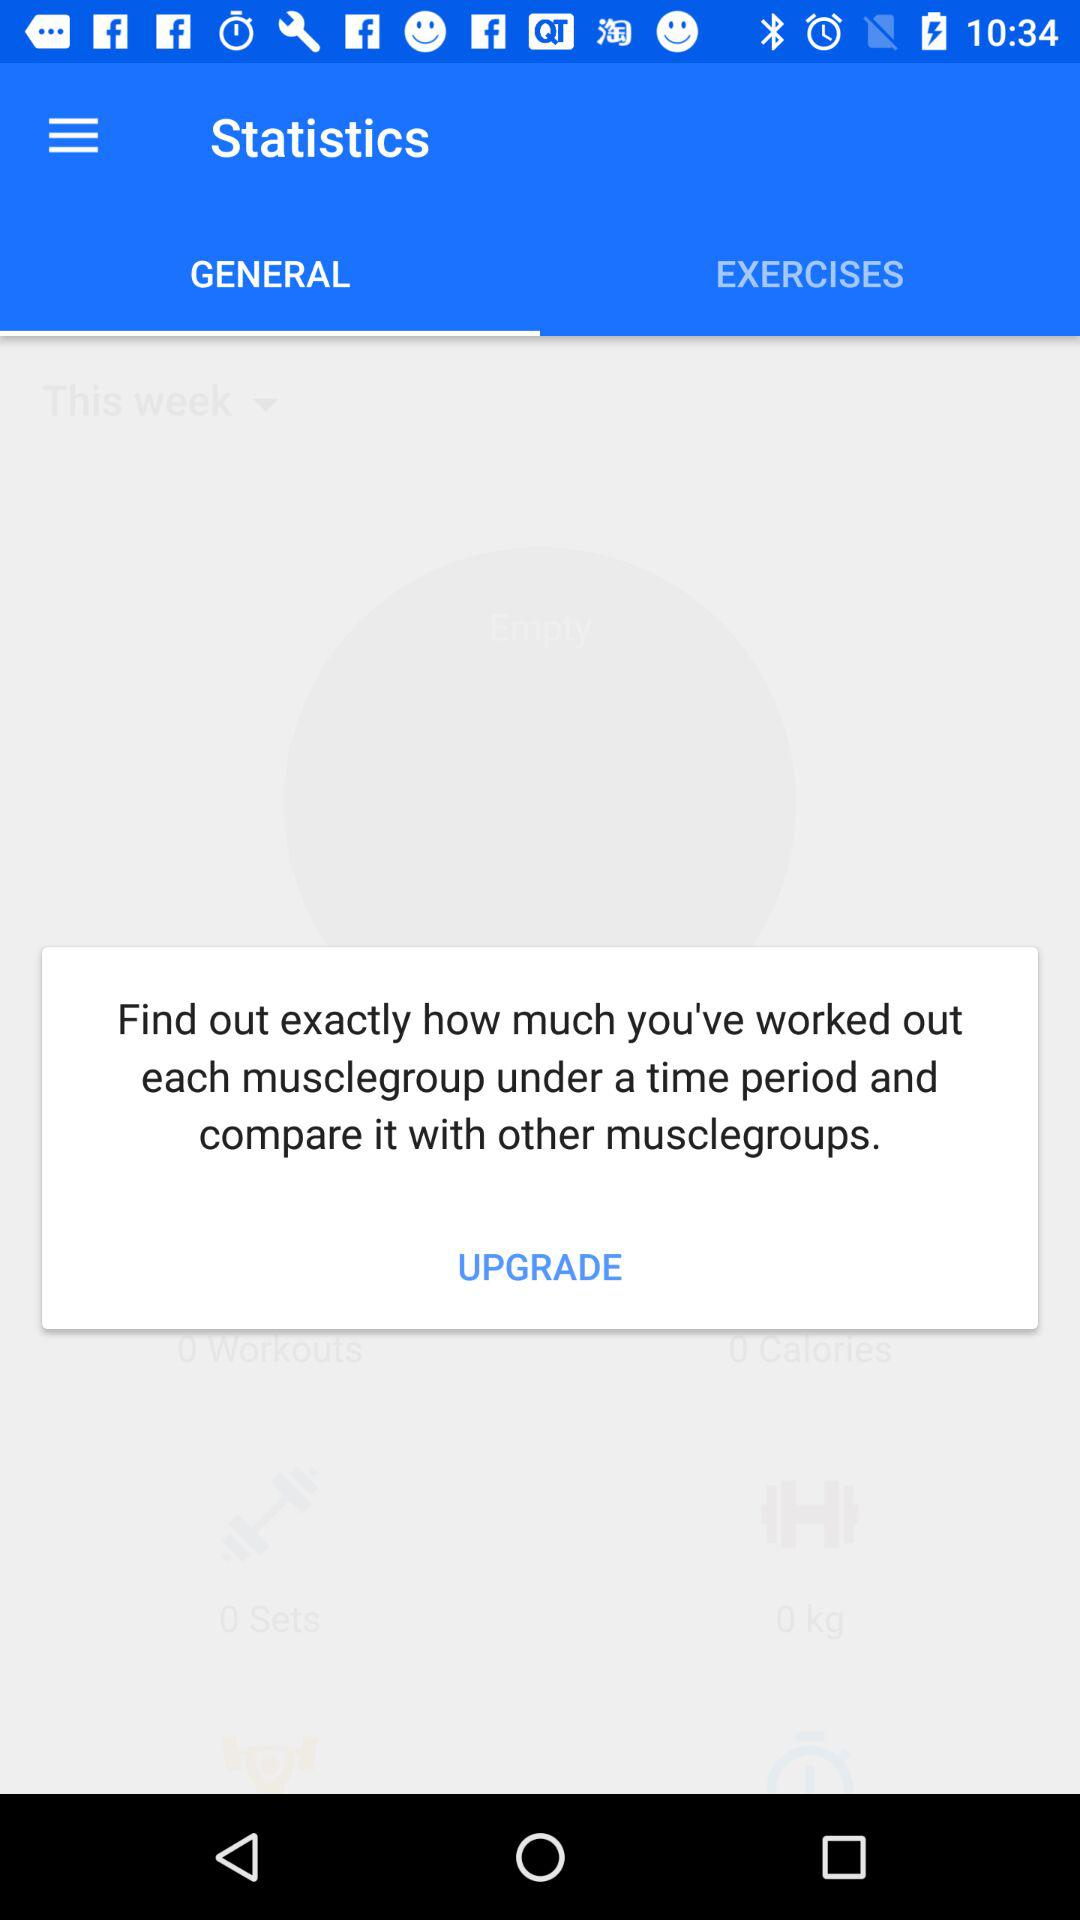Which tab is selected? The selected tab is "GENERAL". 